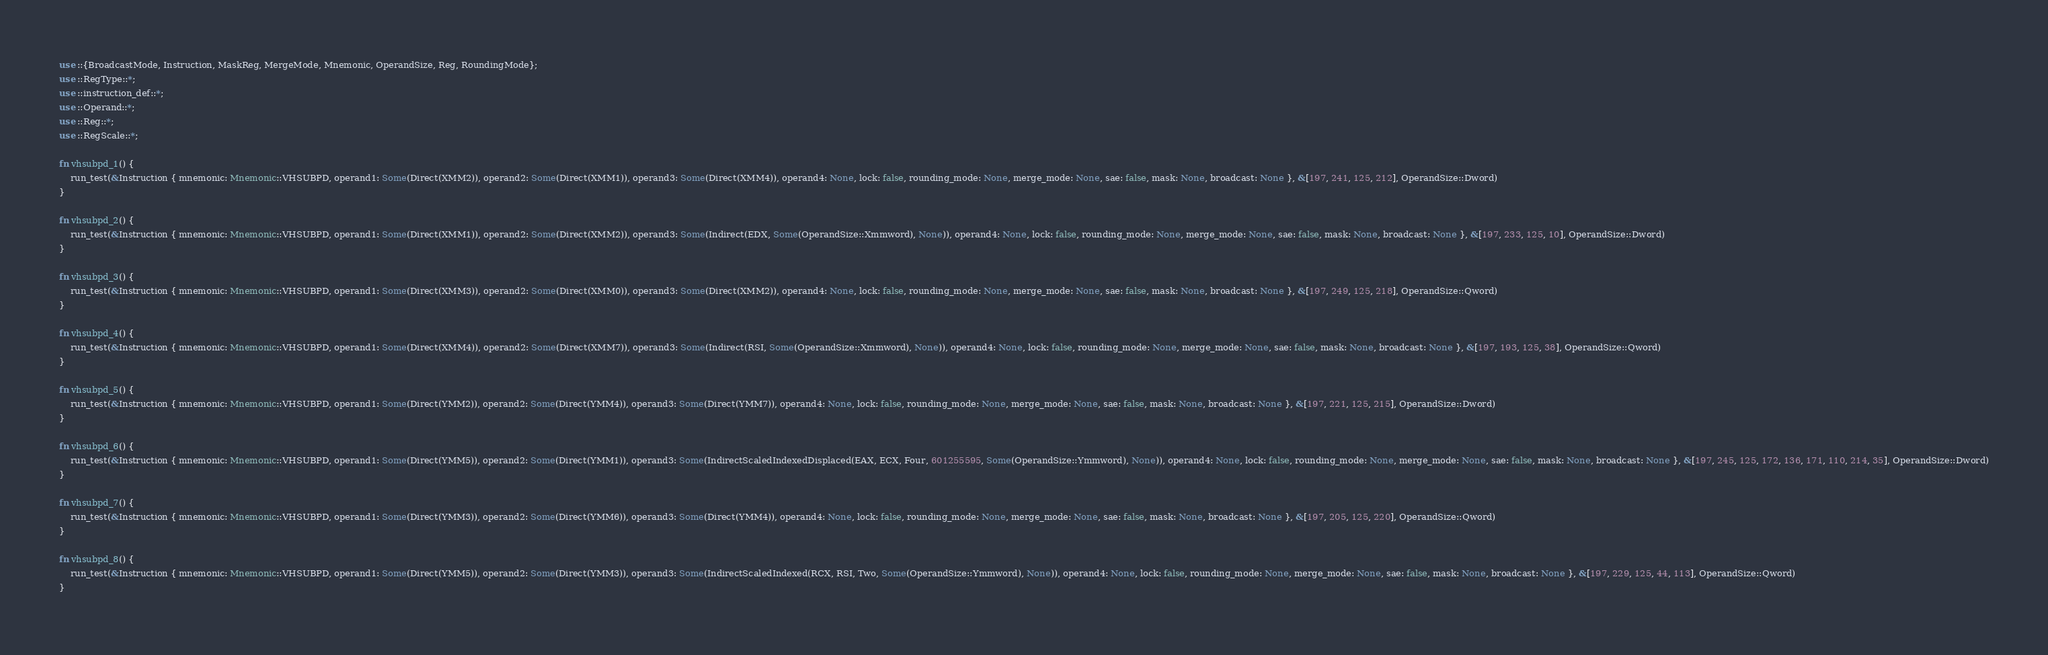Convert code to text. <code><loc_0><loc_0><loc_500><loc_500><_Rust_>use ::{BroadcastMode, Instruction, MaskReg, MergeMode, Mnemonic, OperandSize, Reg, RoundingMode};
use ::RegType::*;
use ::instruction_def::*;
use ::Operand::*;
use ::Reg::*;
use ::RegScale::*;

fn vhsubpd_1() {
    run_test(&Instruction { mnemonic: Mnemonic::VHSUBPD, operand1: Some(Direct(XMM2)), operand2: Some(Direct(XMM1)), operand3: Some(Direct(XMM4)), operand4: None, lock: false, rounding_mode: None, merge_mode: None, sae: false, mask: None, broadcast: None }, &[197, 241, 125, 212], OperandSize::Dword)
}

fn vhsubpd_2() {
    run_test(&Instruction { mnemonic: Mnemonic::VHSUBPD, operand1: Some(Direct(XMM1)), operand2: Some(Direct(XMM2)), operand3: Some(Indirect(EDX, Some(OperandSize::Xmmword), None)), operand4: None, lock: false, rounding_mode: None, merge_mode: None, sae: false, mask: None, broadcast: None }, &[197, 233, 125, 10], OperandSize::Dword)
}

fn vhsubpd_3() {
    run_test(&Instruction { mnemonic: Mnemonic::VHSUBPD, operand1: Some(Direct(XMM3)), operand2: Some(Direct(XMM0)), operand3: Some(Direct(XMM2)), operand4: None, lock: false, rounding_mode: None, merge_mode: None, sae: false, mask: None, broadcast: None }, &[197, 249, 125, 218], OperandSize::Qword)
}

fn vhsubpd_4() {
    run_test(&Instruction { mnemonic: Mnemonic::VHSUBPD, operand1: Some(Direct(XMM4)), operand2: Some(Direct(XMM7)), operand3: Some(Indirect(RSI, Some(OperandSize::Xmmword), None)), operand4: None, lock: false, rounding_mode: None, merge_mode: None, sae: false, mask: None, broadcast: None }, &[197, 193, 125, 38], OperandSize::Qword)
}

fn vhsubpd_5() {
    run_test(&Instruction { mnemonic: Mnemonic::VHSUBPD, operand1: Some(Direct(YMM2)), operand2: Some(Direct(YMM4)), operand3: Some(Direct(YMM7)), operand4: None, lock: false, rounding_mode: None, merge_mode: None, sae: false, mask: None, broadcast: None }, &[197, 221, 125, 215], OperandSize::Dword)
}

fn vhsubpd_6() {
    run_test(&Instruction { mnemonic: Mnemonic::VHSUBPD, operand1: Some(Direct(YMM5)), operand2: Some(Direct(YMM1)), operand3: Some(IndirectScaledIndexedDisplaced(EAX, ECX, Four, 601255595, Some(OperandSize::Ymmword), None)), operand4: None, lock: false, rounding_mode: None, merge_mode: None, sae: false, mask: None, broadcast: None }, &[197, 245, 125, 172, 136, 171, 110, 214, 35], OperandSize::Dword)
}

fn vhsubpd_7() {
    run_test(&Instruction { mnemonic: Mnemonic::VHSUBPD, operand1: Some(Direct(YMM3)), operand2: Some(Direct(YMM6)), operand3: Some(Direct(YMM4)), operand4: None, lock: false, rounding_mode: None, merge_mode: None, sae: false, mask: None, broadcast: None }, &[197, 205, 125, 220], OperandSize::Qword)
}

fn vhsubpd_8() {
    run_test(&Instruction { mnemonic: Mnemonic::VHSUBPD, operand1: Some(Direct(YMM5)), operand2: Some(Direct(YMM3)), operand3: Some(IndirectScaledIndexed(RCX, RSI, Two, Some(OperandSize::Ymmword), None)), operand4: None, lock: false, rounding_mode: None, merge_mode: None, sae: false, mask: None, broadcast: None }, &[197, 229, 125, 44, 113], OperandSize::Qword)
}

</code> 